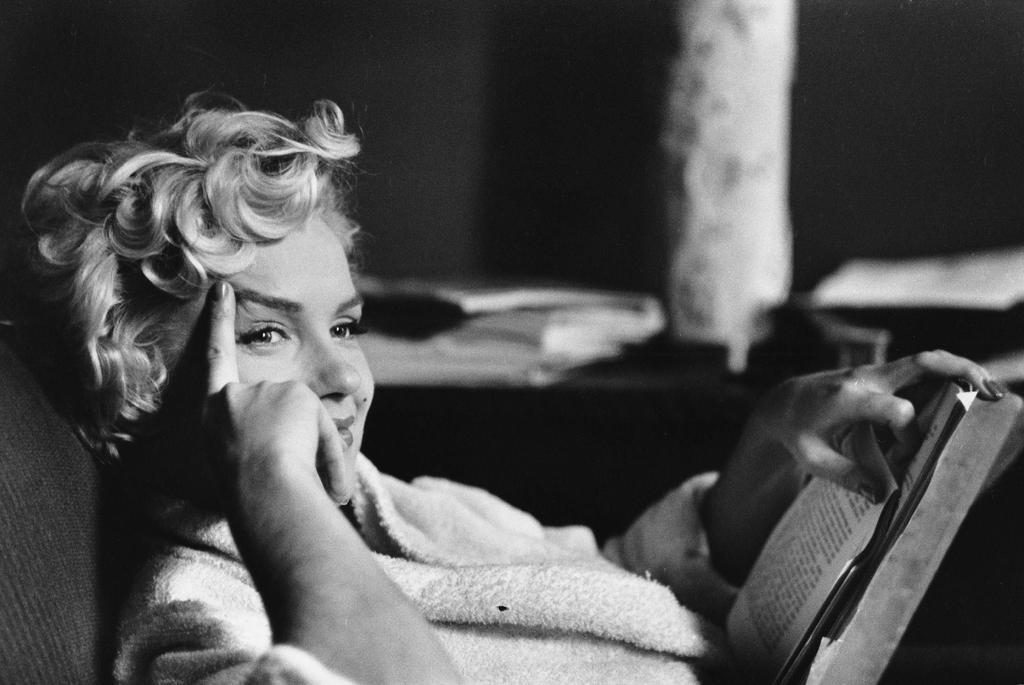Could you give a brief overview of what you see in this image? There is a woman smiling and holding a book. In the background it is blur. 